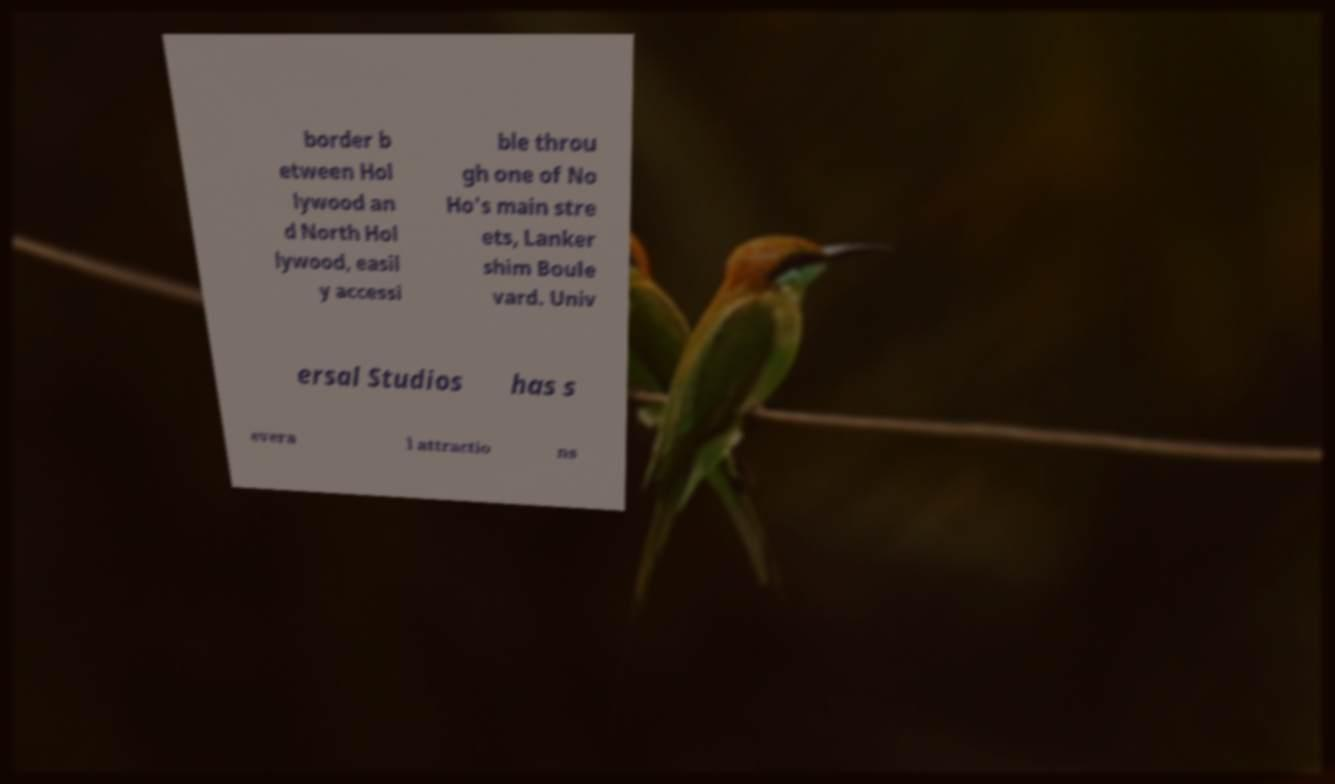What messages or text are displayed in this image? I need them in a readable, typed format. border b etween Hol lywood an d North Hol lywood, easil y accessi ble throu gh one of No Ho's main stre ets, Lanker shim Boule vard. Univ ersal Studios has s evera l attractio ns 